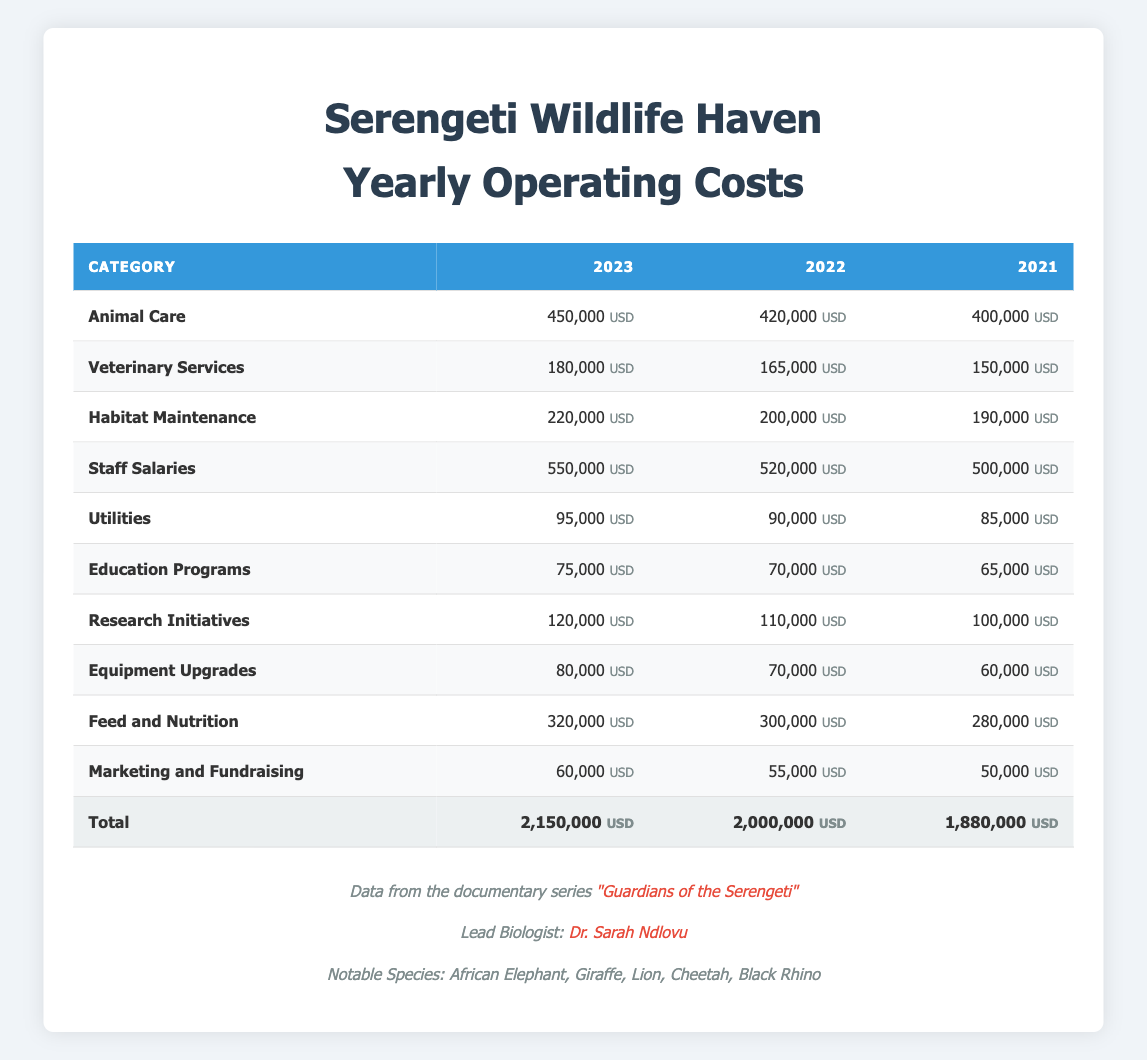What were the total operating costs for Serengeti Wildlife Haven in 2023? The total operating costs for 2023 can be found in the last row of the table under the "Total" category. It shows 2,150,000 USD.
Answer: 2,150,000 USD How much did the sanctuary spend on veterinary services in 2022? Looking at the 2022 column and the Veterinary Services row, the value is 165,000 USD.
Answer: 165,000 USD What was the increase in animal care costs from 2021 to 2023? To find the increase, subtract the animal care cost in 2021 (400,000 USD) from the cost in 2023 (450,000 USD). The increase is 450,000 - 400,000 = 50,000 USD.
Answer: 50,000 USD Did the habitat maintenance costs decrease from 2021 to 2022? Checking the values for Habitat Maintenance, 2021 was 190,000 USD and 2022 was 200,000 USD. Since 200,000 is greater than 190,000, it did not decrease.
Answer: No What is the average amount spent on utilities over the three years? To find the average, sum the utilities for all years: 95,000 (2023) + 90,000 (2022) + 85,000 (2021) = 270,000 USD. Then divide by 3 (the number of years): 270,000 / 3 = 90,000 USD.
Answer: 90,000 USD Which year had the highest expenditure on research initiatives? Comparing the values for Research Initiatives across the three years, 120,000 USD in 2023 is the highest, as 110,000 (2022) and 100,000 (2021) are lower.
Answer: 2023 What was the total cost for education programs over 2021 and 2022 combined? To find the total for Education Programs, add the amounts for both years: 70,000 (2022) + 65,000 (2021) = 135,000 USD.
Answer: 135,000 USD What percentage did staff salaries increase from 2021 to 2023? First, find the difference in staff salaries: 550,000 (2023) - 500,000 (2021) = 50,000 USD. Then divide the increase by the 2021 figure: 50,000 / 500,000 = 0.1. To convert to percentage, multiply by 100, resulting in 10%.
Answer: 10% 